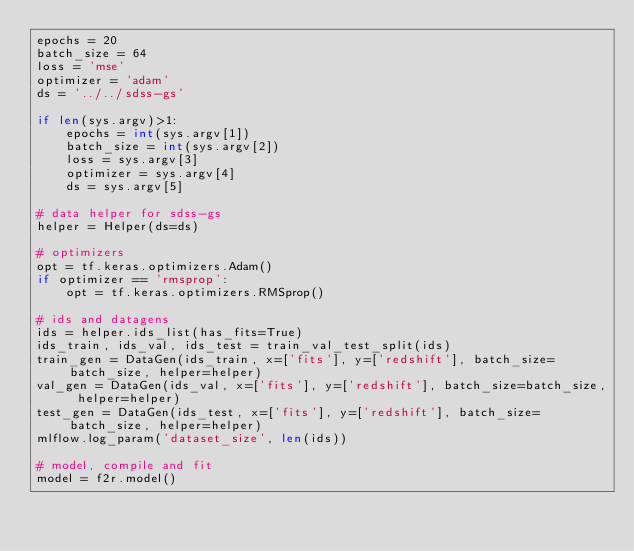<code> <loc_0><loc_0><loc_500><loc_500><_Python_>epochs = 20
batch_size = 64
loss = 'mse'
optimizer = 'adam'
ds = '../../sdss-gs'

if len(sys.argv)>1:
    epochs = int(sys.argv[1])
    batch_size = int(sys.argv[2])
    loss = sys.argv[3]
    optimizer = sys.argv[4]
    ds = sys.argv[5]

# data helper for sdss-gs
helper = Helper(ds=ds)

# optimizers
opt = tf.keras.optimizers.Adam()
if optimizer == 'rmsprop':
    opt = tf.keras.optimizers.RMSprop()

# ids and datagens
ids = helper.ids_list(has_fits=True)
ids_train, ids_val, ids_test = train_val_test_split(ids)
train_gen = DataGen(ids_train, x=['fits'], y=['redshift'], batch_size=batch_size, helper=helper)
val_gen = DataGen(ids_val, x=['fits'], y=['redshift'], batch_size=batch_size, helper=helper)
test_gen = DataGen(ids_test, x=['fits'], y=['redshift'], batch_size=batch_size, helper=helper)
mlflow.log_param('dataset_size', len(ids))

# model, compile and fit
model = f2r.model()</code> 